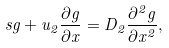<formula> <loc_0><loc_0><loc_500><loc_500>s g + u _ { 2 } \frac { \partial g } { \partial x } = D _ { 2 } \frac { \partial ^ { 2 } g } { \partial x ^ { 2 } } ,</formula> 